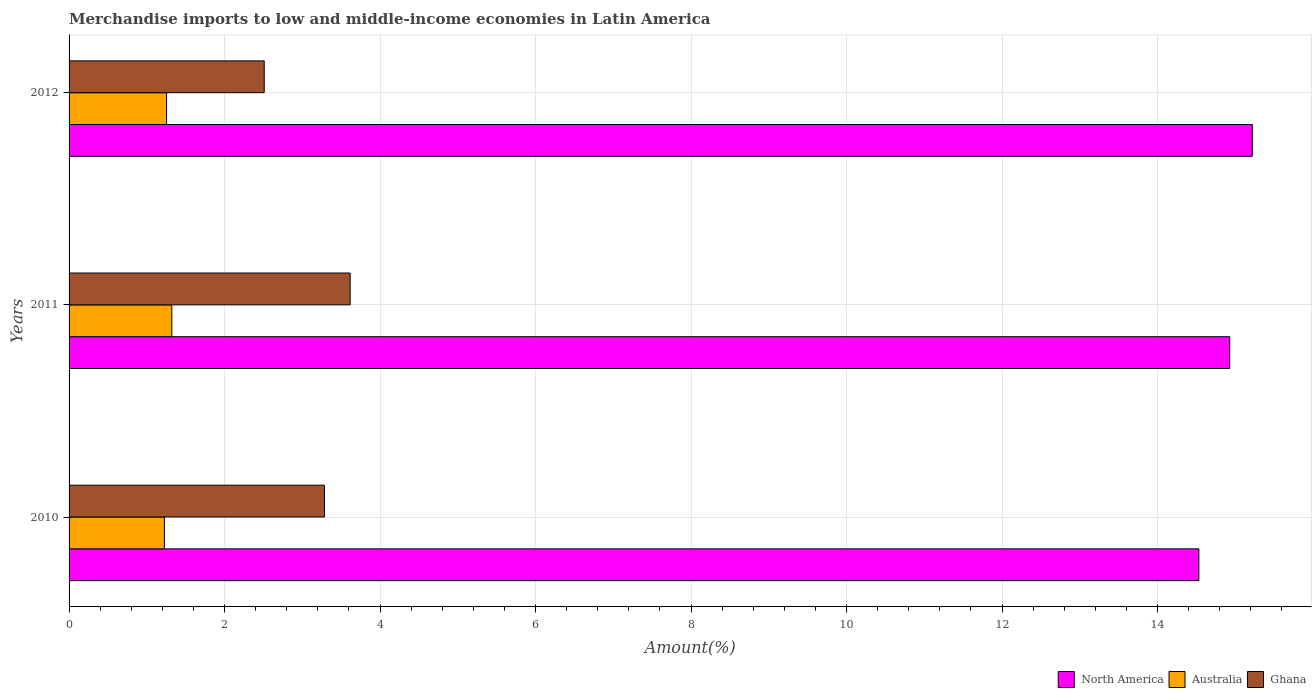Are the number of bars per tick equal to the number of legend labels?
Provide a succinct answer. Yes. Are the number of bars on each tick of the Y-axis equal?
Give a very brief answer. Yes. How many bars are there on the 3rd tick from the bottom?
Your answer should be compact. 3. What is the label of the 3rd group of bars from the top?
Your answer should be compact. 2010. What is the percentage of amount earned from merchandise imports in Australia in 2011?
Ensure brevity in your answer.  1.32. Across all years, what is the maximum percentage of amount earned from merchandise imports in Australia?
Provide a short and direct response. 1.32. Across all years, what is the minimum percentage of amount earned from merchandise imports in North America?
Ensure brevity in your answer.  14.53. In which year was the percentage of amount earned from merchandise imports in North America maximum?
Keep it short and to the point. 2012. In which year was the percentage of amount earned from merchandise imports in North America minimum?
Offer a very short reply. 2010. What is the total percentage of amount earned from merchandise imports in North America in the graph?
Offer a very short reply. 44.68. What is the difference between the percentage of amount earned from merchandise imports in Ghana in 2010 and that in 2011?
Your response must be concise. -0.33. What is the difference between the percentage of amount earned from merchandise imports in North America in 2010 and the percentage of amount earned from merchandise imports in Ghana in 2011?
Make the answer very short. 10.92. What is the average percentage of amount earned from merchandise imports in Ghana per year?
Your response must be concise. 3.14. In the year 2011, what is the difference between the percentage of amount earned from merchandise imports in North America and percentage of amount earned from merchandise imports in Australia?
Your answer should be compact. 13.61. What is the ratio of the percentage of amount earned from merchandise imports in Ghana in 2010 to that in 2012?
Your answer should be very brief. 1.31. What is the difference between the highest and the second highest percentage of amount earned from merchandise imports in Ghana?
Your answer should be very brief. 0.33. What is the difference between the highest and the lowest percentage of amount earned from merchandise imports in North America?
Keep it short and to the point. 0.69. In how many years, is the percentage of amount earned from merchandise imports in Ghana greater than the average percentage of amount earned from merchandise imports in Ghana taken over all years?
Offer a terse response. 2. Is the sum of the percentage of amount earned from merchandise imports in North America in 2010 and 2012 greater than the maximum percentage of amount earned from merchandise imports in Australia across all years?
Keep it short and to the point. Yes. What does the 2nd bar from the bottom in 2012 represents?
Your answer should be very brief. Australia. Is it the case that in every year, the sum of the percentage of amount earned from merchandise imports in Ghana and percentage of amount earned from merchandise imports in North America is greater than the percentage of amount earned from merchandise imports in Australia?
Give a very brief answer. Yes. How many bars are there?
Your answer should be compact. 9. Are all the bars in the graph horizontal?
Ensure brevity in your answer.  Yes. Are the values on the major ticks of X-axis written in scientific E-notation?
Provide a succinct answer. No. Does the graph contain any zero values?
Offer a very short reply. No. Where does the legend appear in the graph?
Ensure brevity in your answer.  Bottom right. How many legend labels are there?
Keep it short and to the point. 3. What is the title of the graph?
Provide a succinct answer. Merchandise imports to low and middle-income economies in Latin America. What is the label or title of the X-axis?
Your response must be concise. Amount(%). What is the label or title of the Y-axis?
Offer a very short reply. Years. What is the Amount(%) in North America in 2010?
Make the answer very short. 14.53. What is the Amount(%) in Australia in 2010?
Your response must be concise. 1.23. What is the Amount(%) of Ghana in 2010?
Your answer should be very brief. 3.29. What is the Amount(%) of North America in 2011?
Make the answer very short. 14.93. What is the Amount(%) in Australia in 2011?
Your answer should be compact. 1.32. What is the Amount(%) in Ghana in 2011?
Provide a succinct answer. 3.62. What is the Amount(%) in North America in 2012?
Provide a short and direct response. 15.22. What is the Amount(%) of Australia in 2012?
Your response must be concise. 1.25. What is the Amount(%) of Ghana in 2012?
Your answer should be very brief. 2.51. Across all years, what is the maximum Amount(%) in North America?
Give a very brief answer. 15.22. Across all years, what is the maximum Amount(%) in Australia?
Keep it short and to the point. 1.32. Across all years, what is the maximum Amount(%) in Ghana?
Your answer should be compact. 3.62. Across all years, what is the minimum Amount(%) of North America?
Give a very brief answer. 14.53. Across all years, what is the minimum Amount(%) of Australia?
Make the answer very short. 1.23. Across all years, what is the minimum Amount(%) in Ghana?
Offer a very short reply. 2.51. What is the total Amount(%) in North America in the graph?
Make the answer very short. 44.68. What is the total Amount(%) of Australia in the graph?
Make the answer very short. 3.8. What is the total Amount(%) of Ghana in the graph?
Give a very brief answer. 9.41. What is the difference between the Amount(%) of North America in 2010 and that in 2011?
Provide a succinct answer. -0.4. What is the difference between the Amount(%) in Australia in 2010 and that in 2011?
Provide a succinct answer. -0.1. What is the difference between the Amount(%) of Ghana in 2010 and that in 2011?
Your response must be concise. -0.33. What is the difference between the Amount(%) of North America in 2010 and that in 2012?
Keep it short and to the point. -0.69. What is the difference between the Amount(%) in Australia in 2010 and that in 2012?
Provide a succinct answer. -0.03. What is the difference between the Amount(%) of Ghana in 2010 and that in 2012?
Your response must be concise. 0.78. What is the difference between the Amount(%) in North America in 2011 and that in 2012?
Keep it short and to the point. -0.29. What is the difference between the Amount(%) in Australia in 2011 and that in 2012?
Give a very brief answer. 0.07. What is the difference between the Amount(%) in Ghana in 2011 and that in 2012?
Provide a short and direct response. 1.11. What is the difference between the Amount(%) of North America in 2010 and the Amount(%) of Australia in 2011?
Provide a succinct answer. 13.21. What is the difference between the Amount(%) in North America in 2010 and the Amount(%) in Ghana in 2011?
Provide a succinct answer. 10.92. What is the difference between the Amount(%) of Australia in 2010 and the Amount(%) of Ghana in 2011?
Ensure brevity in your answer.  -2.39. What is the difference between the Amount(%) of North America in 2010 and the Amount(%) of Australia in 2012?
Offer a terse response. 13.28. What is the difference between the Amount(%) of North America in 2010 and the Amount(%) of Ghana in 2012?
Offer a terse response. 12.02. What is the difference between the Amount(%) of Australia in 2010 and the Amount(%) of Ghana in 2012?
Ensure brevity in your answer.  -1.28. What is the difference between the Amount(%) of North America in 2011 and the Amount(%) of Australia in 2012?
Give a very brief answer. 13.67. What is the difference between the Amount(%) in North America in 2011 and the Amount(%) in Ghana in 2012?
Your answer should be compact. 12.42. What is the difference between the Amount(%) in Australia in 2011 and the Amount(%) in Ghana in 2012?
Give a very brief answer. -1.19. What is the average Amount(%) in North America per year?
Keep it short and to the point. 14.89. What is the average Amount(%) in Australia per year?
Give a very brief answer. 1.27. What is the average Amount(%) in Ghana per year?
Keep it short and to the point. 3.14. In the year 2010, what is the difference between the Amount(%) in North America and Amount(%) in Australia?
Offer a very short reply. 13.31. In the year 2010, what is the difference between the Amount(%) in North America and Amount(%) in Ghana?
Your answer should be compact. 11.25. In the year 2010, what is the difference between the Amount(%) of Australia and Amount(%) of Ghana?
Your response must be concise. -2.06. In the year 2011, what is the difference between the Amount(%) of North America and Amount(%) of Australia?
Provide a short and direct response. 13.61. In the year 2011, what is the difference between the Amount(%) of North America and Amount(%) of Ghana?
Your answer should be compact. 11.31. In the year 2011, what is the difference between the Amount(%) of Australia and Amount(%) of Ghana?
Your answer should be very brief. -2.29. In the year 2012, what is the difference between the Amount(%) in North America and Amount(%) in Australia?
Offer a very short reply. 13.96. In the year 2012, what is the difference between the Amount(%) of North America and Amount(%) of Ghana?
Offer a very short reply. 12.71. In the year 2012, what is the difference between the Amount(%) in Australia and Amount(%) in Ghana?
Ensure brevity in your answer.  -1.26. What is the ratio of the Amount(%) of North America in 2010 to that in 2011?
Offer a terse response. 0.97. What is the ratio of the Amount(%) of Australia in 2010 to that in 2011?
Your answer should be compact. 0.93. What is the ratio of the Amount(%) in Ghana in 2010 to that in 2011?
Offer a very short reply. 0.91. What is the ratio of the Amount(%) in North America in 2010 to that in 2012?
Offer a terse response. 0.95. What is the ratio of the Amount(%) in Australia in 2010 to that in 2012?
Make the answer very short. 0.98. What is the ratio of the Amount(%) of Ghana in 2010 to that in 2012?
Ensure brevity in your answer.  1.31. What is the ratio of the Amount(%) in North America in 2011 to that in 2012?
Keep it short and to the point. 0.98. What is the ratio of the Amount(%) in Australia in 2011 to that in 2012?
Your answer should be very brief. 1.05. What is the ratio of the Amount(%) in Ghana in 2011 to that in 2012?
Ensure brevity in your answer.  1.44. What is the difference between the highest and the second highest Amount(%) in North America?
Offer a very short reply. 0.29. What is the difference between the highest and the second highest Amount(%) in Australia?
Ensure brevity in your answer.  0.07. What is the difference between the highest and the second highest Amount(%) of Ghana?
Your answer should be compact. 0.33. What is the difference between the highest and the lowest Amount(%) in North America?
Offer a very short reply. 0.69. What is the difference between the highest and the lowest Amount(%) of Australia?
Keep it short and to the point. 0.1. What is the difference between the highest and the lowest Amount(%) of Ghana?
Make the answer very short. 1.11. 